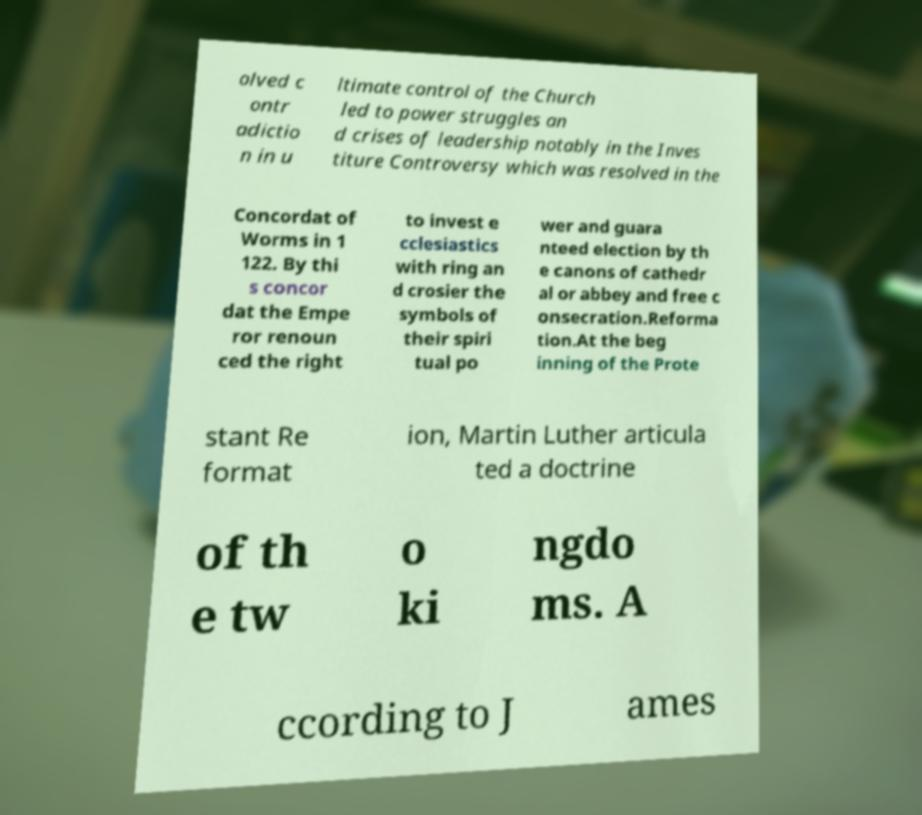There's text embedded in this image that I need extracted. Can you transcribe it verbatim? olved c ontr adictio n in u ltimate control of the Church led to power struggles an d crises of leadership notably in the Inves titure Controversy which was resolved in the Concordat of Worms in 1 122. By thi s concor dat the Empe ror renoun ced the right to invest e cclesiastics with ring an d crosier the symbols of their spiri tual po wer and guara nteed election by th e canons of cathedr al or abbey and free c onsecration.Reforma tion.At the beg inning of the Prote stant Re format ion, Martin Luther articula ted a doctrine of th e tw o ki ngdo ms. A ccording to J ames 